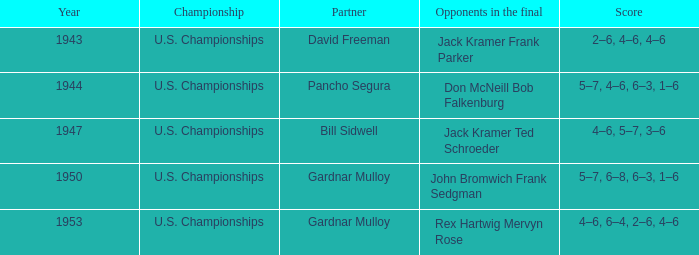Which competitors in the final have a score of 4-6, 6-4, 2-6, 4-6? Rex Hartwig Mervyn Rose. Could you parse the entire table as a dict? {'header': ['Year', 'Championship', 'Partner', 'Opponents in the final', 'Score'], 'rows': [['1943', 'U.S. Championships', 'David Freeman', 'Jack Kramer Frank Parker', '2–6, 4–6, 4–6'], ['1944', 'U.S. Championships', 'Pancho Segura', 'Don McNeill Bob Falkenburg', '5–7, 4–6, 6–3, 1–6'], ['1947', 'U.S. Championships', 'Bill Sidwell', 'Jack Kramer Ted Schroeder', '4–6, 5–7, 3–6'], ['1950', 'U.S. Championships', 'Gardnar Mulloy', 'John Bromwich Frank Sedgman', '5–7, 6–8, 6–3, 1–6'], ['1953', 'U.S. Championships', 'Gardnar Mulloy', 'Rex Hartwig Mervyn Rose', '4–6, 6–4, 2–6, 4–6']]} 